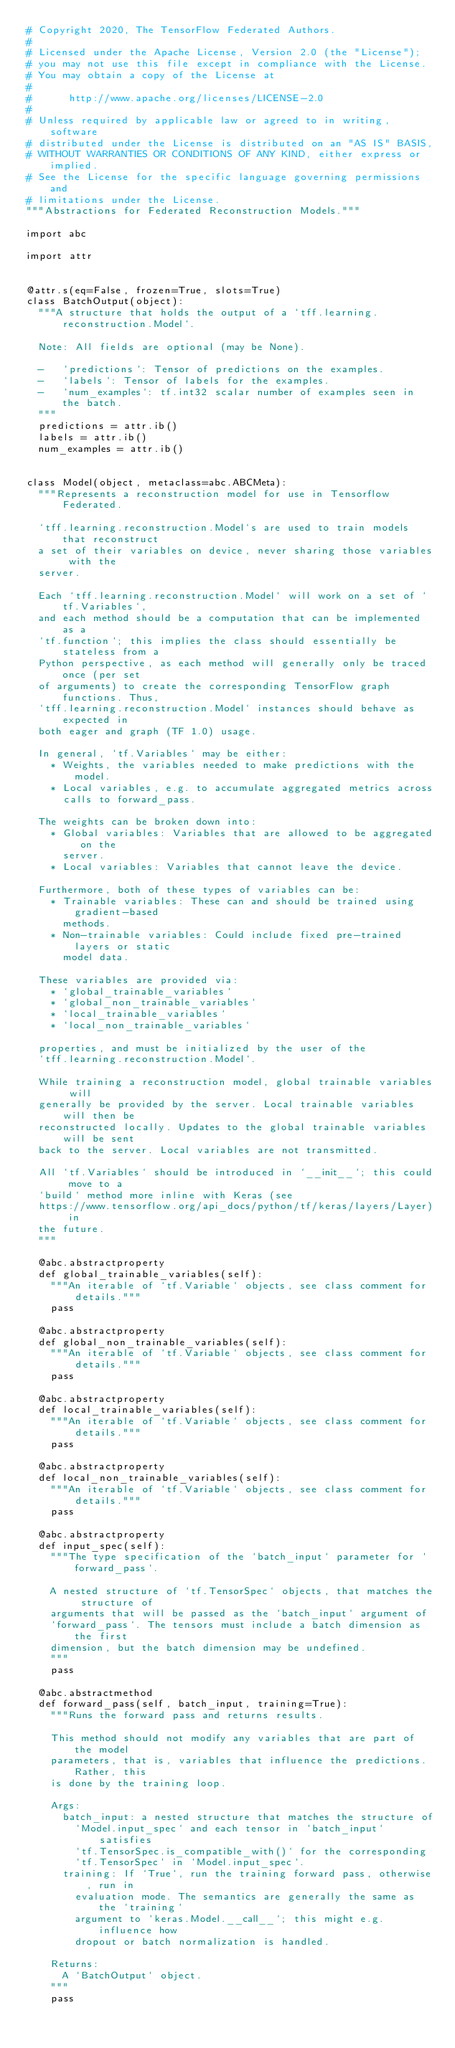Convert code to text. <code><loc_0><loc_0><loc_500><loc_500><_Python_># Copyright 2020, The TensorFlow Federated Authors.
#
# Licensed under the Apache License, Version 2.0 (the "License");
# you may not use this file except in compliance with the License.
# You may obtain a copy of the License at
#
#      http://www.apache.org/licenses/LICENSE-2.0
#
# Unless required by applicable law or agreed to in writing, software
# distributed under the License is distributed on an "AS IS" BASIS,
# WITHOUT WARRANTIES OR CONDITIONS OF ANY KIND, either express or implied.
# See the License for the specific language governing permissions and
# limitations under the License.
"""Abstractions for Federated Reconstruction Models."""

import abc

import attr


@attr.s(eq=False, frozen=True, slots=True)
class BatchOutput(object):
  """A structure that holds the output of a `tff.learning.reconstruction.Model`.

  Note: All fields are optional (may be None).

  -   `predictions`: Tensor of predictions on the examples.
  -   `labels`: Tensor of labels for the examples.
  -   `num_examples`: tf.int32 scalar number of examples seen in the batch.
  """
  predictions = attr.ib()
  labels = attr.ib()
  num_examples = attr.ib()


class Model(object, metaclass=abc.ABCMeta):
  """Represents a reconstruction model for use in Tensorflow Federated.

  `tff.learning.reconstruction.Model`s are used to train models that reconstruct
  a set of their variables on device, never sharing those variables with the
  server.

  Each `tff.learning.reconstruction.Model` will work on a set of `tf.Variables`,
  and each method should be a computation that can be implemented as a
  `tf.function`; this implies the class should essentially be stateless from a
  Python perspective, as each method will generally only be traced once (per set
  of arguments) to create the corresponding TensorFlow graph functions. Thus,
  `tff.learning.reconstruction.Model` instances should behave as expected in
  both eager and graph (TF 1.0) usage.

  In general, `tf.Variables` may be either:
    * Weights, the variables needed to make predictions with the model.
    * Local variables, e.g. to accumulate aggregated metrics across
      calls to forward_pass.

  The weights can be broken down into:
    * Global variables: Variables that are allowed to be aggregated on the
      server.
    * Local variables: Variables that cannot leave the device.

  Furthermore, both of these types of variables can be:
    * Trainable variables: These can and should be trained using gradient-based
      methods.
    * Non-trainable variables: Could include fixed pre-trained layers or static
      model data.

  These variables are provided via:
    * `global_trainable_variables`
    * `global_non_trainable_variables`
    * `local_trainable_variables`
    * `local_non_trainable_variables`

  properties, and must be initialized by the user of the
  `tff.learning.reconstruction.Model`.

  While training a reconstruction model, global trainable variables will
  generally be provided by the server. Local trainable variables will then be
  reconstructed locally. Updates to the global trainable variables will be sent
  back to the server. Local variables are not transmitted.

  All `tf.Variables` should be introduced in `__init__`; this could move to a
  `build` method more inline with Keras (see
  https://www.tensorflow.org/api_docs/python/tf/keras/layers/Layer) in
  the future.
  """

  @abc.abstractproperty
  def global_trainable_variables(self):
    """An iterable of `tf.Variable` objects, see class comment for details."""
    pass

  @abc.abstractproperty
  def global_non_trainable_variables(self):
    """An iterable of `tf.Variable` objects, see class comment for details."""
    pass

  @abc.abstractproperty
  def local_trainable_variables(self):
    """An iterable of `tf.Variable` objects, see class comment for details."""
    pass

  @abc.abstractproperty
  def local_non_trainable_variables(self):
    """An iterable of `tf.Variable` objects, see class comment for details."""
    pass

  @abc.abstractproperty
  def input_spec(self):
    """The type specification of the `batch_input` parameter for `forward_pass`.

    A nested structure of `tf.TensorSpec` objects, that matches the structure of
    arguments that will be passed as the `batch_input` argument of
    `forward_pass`. The tensors must include a batch dimension as the first
    dimension, but the batch dimension may be undefined.
    """
    pass

  @abc.abstractmethod
  def forward_pass(self, batch_input, training=True):
    """Runs the forward pass and returns results.

    This method should not modify any variables that are part of the model
    parameters, that is, variables that influence the predictions. Rather, this
    is done by the training loop.

    Args:
      batch_input: a nested structure that matches the structure of
        `Model.input_spec` and each tensor in `batch_input` satisfies
        `tf.TensorSpec.is_compatible_with()` for the corresponding
        `tf.TensorSpec` in `Model.input_spec`.
      training: If `True`, run the training forward pass, otherwise, run in
        evaluation mode. The semantics are generally the same as the `training`
        argument to `keras.Model.__call__`; this might e.g. influence how
        dropout or batch normalization is handled.

    Returns:
      A `BatchOutput` object.
    """
    pass
</code> 